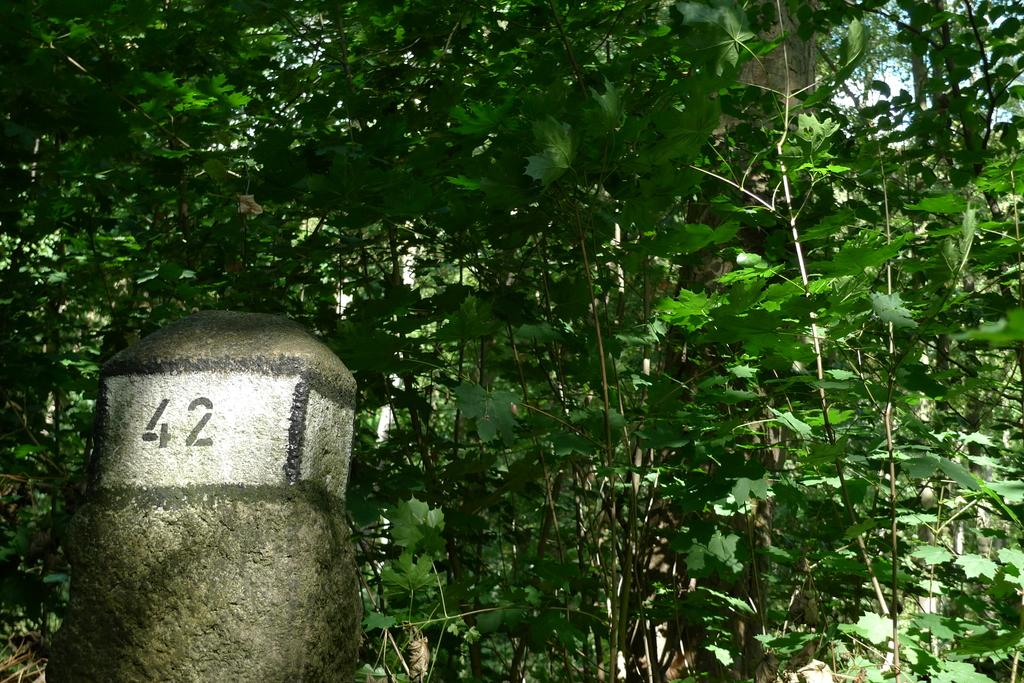What can be seen on the left side of the image? There is a number on a white surface of a pole on the left side of the image. What is visible in the background of the image? There are trees with green leaves in the background of the image. What type of texture can be seen on the giants' skin in the image? There are no giants present in the image, so it is not possible to determine the texture of their skin. 